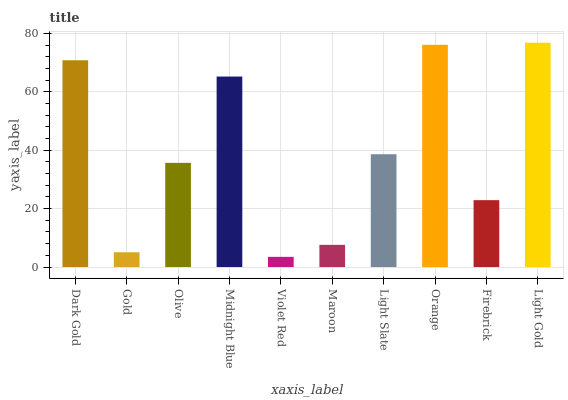Is Violet Red the minimum?
Answer yes or no. Yes. Is Light Gold the maximum?
Answer yes or no. Yes. Is Gold the minimum?
Answer yes or no. No. Is Gold the maximum?
Answer yes or no. No. Is Dark Gold greater than Gold?
Answer yes or no. Yes. Is Gold less than Dark Gold?
Answer yes or no. Yes. Is Gold greater than Dark Gold?
Answer yes or no. No. Is Dark Gold less than Gold?
Answer yes or no. No. Is Light Slate the high median?
Answer yes or no. Yes. Is Olive the low median?
Answer yes or no. Yes. Is Midnight Blue the high median?
Answer yes or no. No. Is Orange the low median?
Answer yes or no. No. 